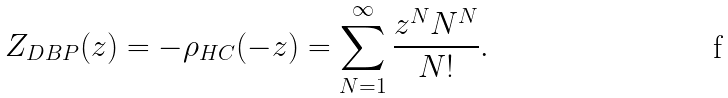Convert formula to latex. <formula><loc_0><loc_0><loc_500><loc_500>Z _ { D B P } ( z ) = - \rho _ { H C } ( - z ) = \sum ^ { \infty } _ { N = 1 } \frac { z ^ { N } N ^ { N } } { N ! } .</formula> 